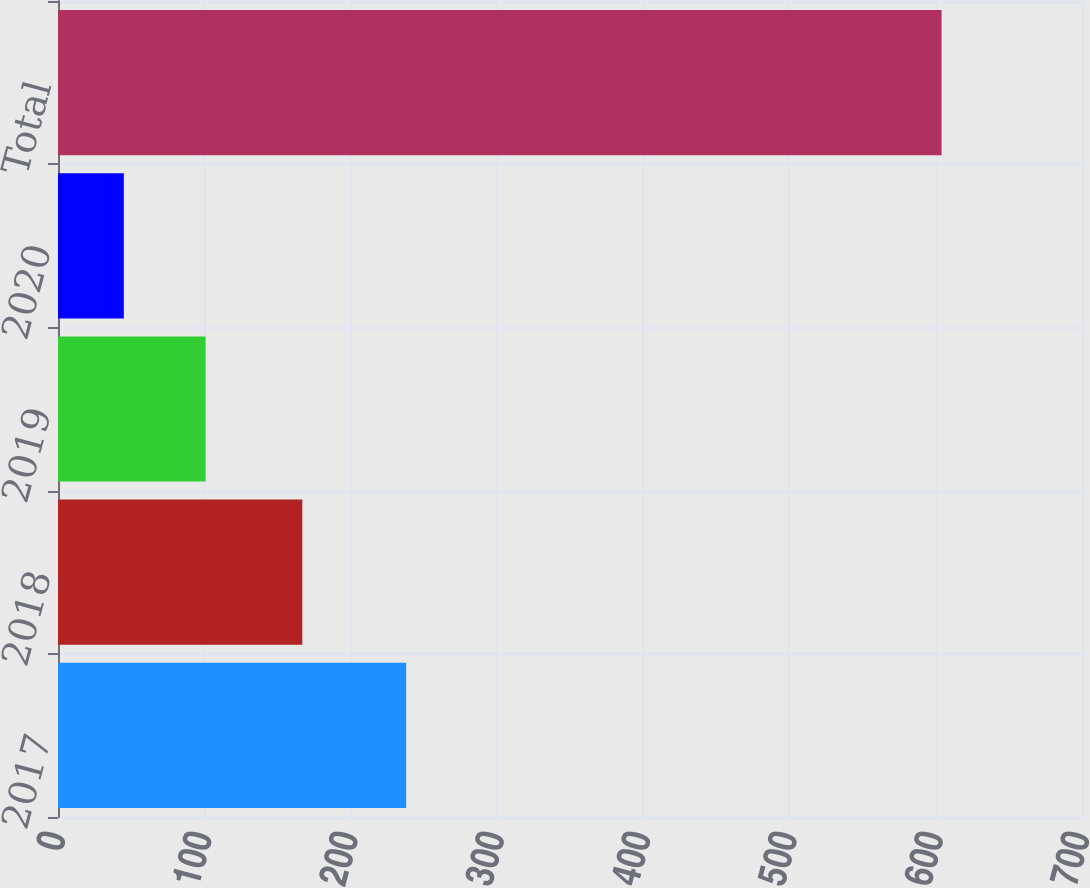Convert chart to OTSL. <chart><loc_0><loc_0><loc_500><loc_500><bar_chart><fcel>2017<fcel>2018<fcel>2019<fcel>2020<fcel>Total<nl><fcel>238<fcel>167<fcel>100.9<fcel>45<fcel>604<nl></chart> 